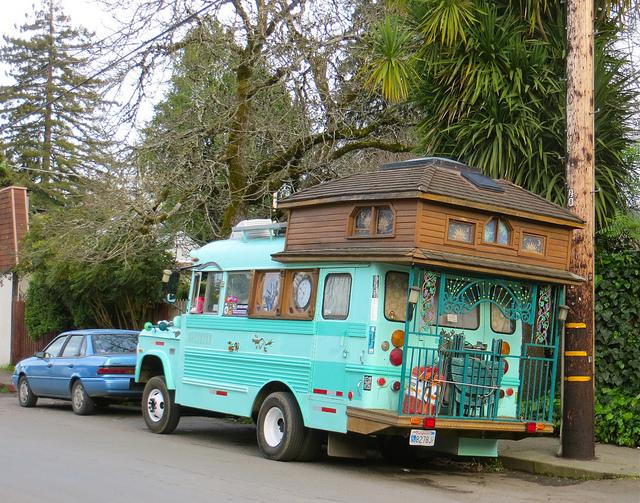Is this a mini house?
Give a very brief answer. Yes. What kind of vehicles are these?
Quick response, please. Bus. Is this a tour bus?
Short answer required. No. What color is the bus?
Give a very brief answer. Blue. Where is this?
Concise answer only. Street. Is this a city bus?
Keep it brief. No. 